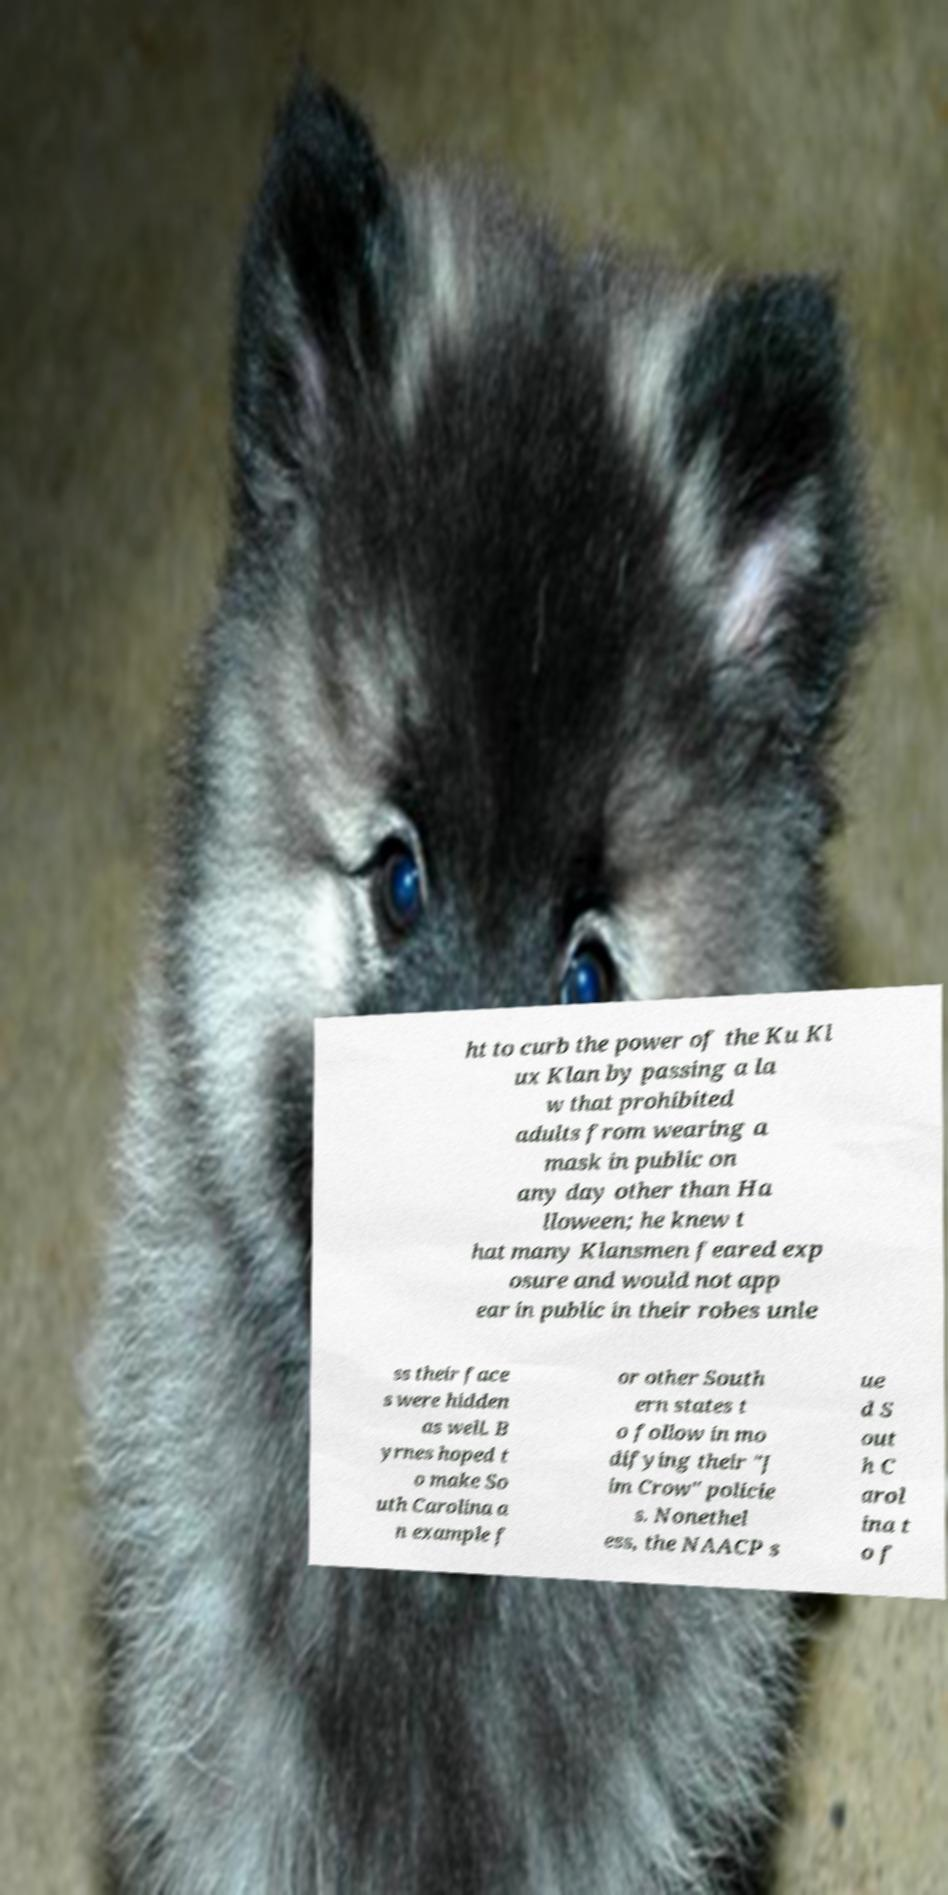What messages or text are displayed in this image? I need them in a readable, typed format. ht to curb the power of the Ku Kl ux Klan by passing a la w that prohibited adults from wearing a mask in public on any day other than Ha lloween; he knew t hat many Klansmen feared exp osure and would not app ear in public in their robes unle ss their face s were hidden as well. B yrnes hoped t o make So uth Carolina a n example f or other South ern states t o follow in mo difying their "J im Crow" policie s. Nonethel ess, the NAACP s ue d S out h C arol ina t o f 